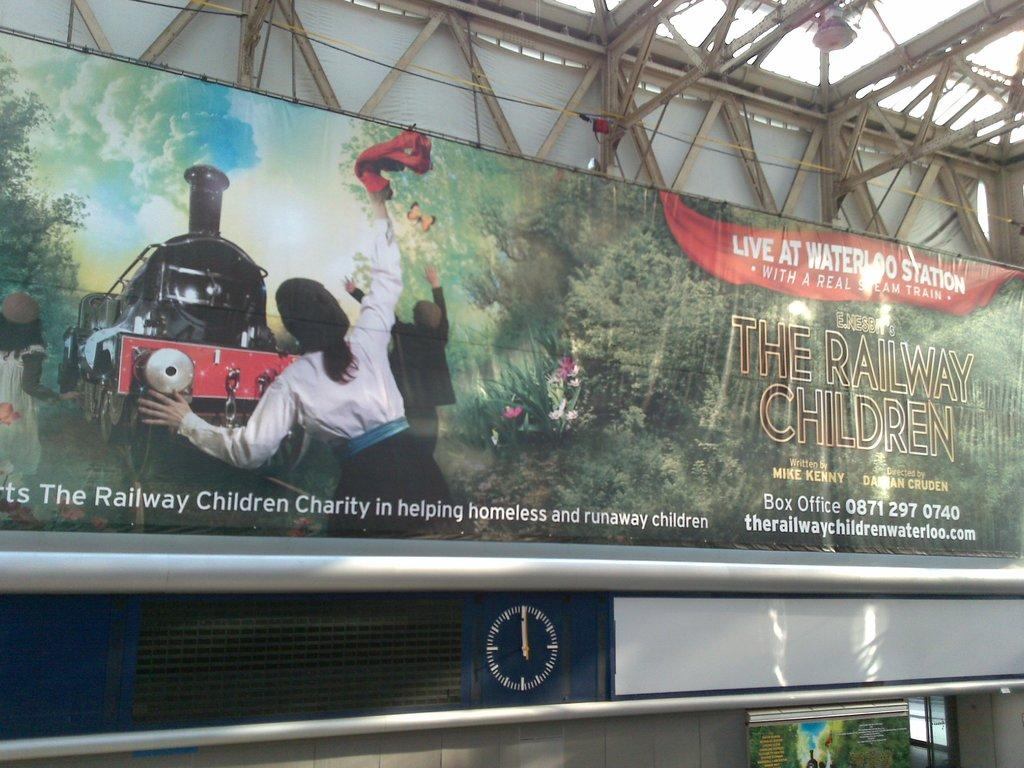<image>
Present a compact description of the photo's key features. a real steam train is being advertised on a sign 